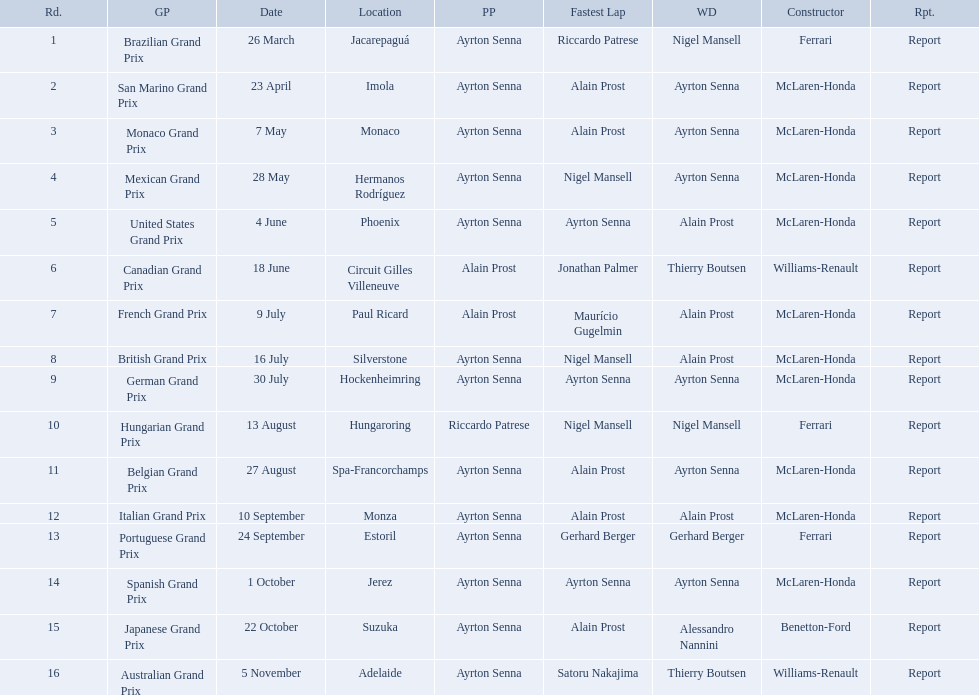What are all of the grand prix run in the 1989 formula one season? Brazilian Grand Prix, San Marino Grand Prix, Monaco Grand Prix, Mexican Grand Prix, United States Grand Prix, Canadian Grand Prix, French Grand Prix, British Grand Prix, German Grand Prix, Hungarian Grand Prix, Belgian Grand Prix, Italian Grand Prix, Portuguese Grand Prix, Spanish Grand Prix, Japanese Grand Prix, Australian Grand Prix. Of those 1989 formula one grand prix, which were run in october? Spanish Grand Prix, Japanese Grand Prix, Australian Grand Prix. Of those 1989 formula one grand prix run in october, which was the only one to be won by benetton-ford? Japanese Grand Prix. 